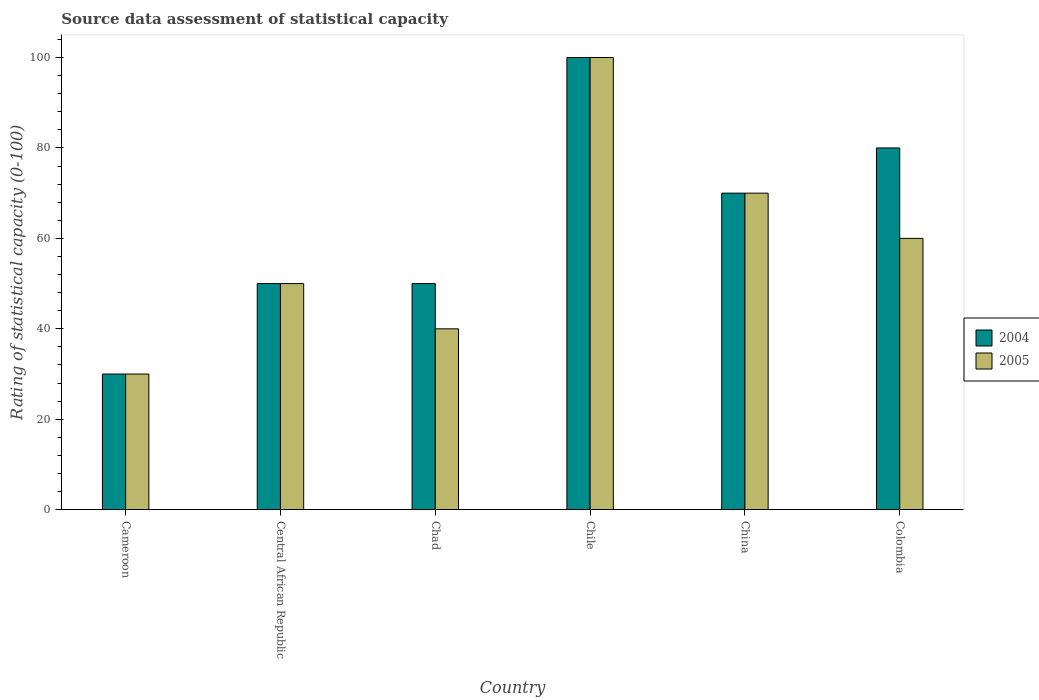How many different coloured bars are there?
Ensure brevity in your answer.  2. How many groups of bars are there?
Offer a very short reply. 6. How many bars are there on the 6th tick from the left?
Offer a very short reply. 2. How many bars are there on the 5th tick from the right?
Give a very brief answer. 2. What is the label of the 5th group of bars from the left?
Ensure brevity in your answer.  China. In which country was the rating of statistical capacity in 2005 minimum?
Make the answer very short. Cameroon. What is the total rating of statistical capacity in 2004 in the graph?
Your answer should be compact. 380. What is the average rating of statistical capacity in 2004 per country?
Your answer should be compact. 63.33. What is the ratio of the rating of statistical capacity in 2004 in Chad to that in China?
Your answer should be very brief. 0.71. Is the difference between the rating of statistical capacity in 2004 in Cameroon and Central African Republic greater than the difference between the rating of statistical capacity in 2005 in Cameroon and Central African Republic?
Your answer should be compact. No. What is the difference between the highest and the lowest rating of statistical capacity in 2005?
Provide a succinct answer. 70. What does the 1st bar from the left in Colombia represents?
Provide a succinct answer. 2004. What does the 2nd bar from the right in Cameroon represents?
Provide a succinct answer. 2004. How many bars are there?
Make the answer very short. 12. Are all the bars in the graph horizontal?
Make the answer very short. No. What is the difference between two consecutive major ticks on the Y-axis?
Provide a short and direct response. 20. Are the values on the major ticks of Y-axis written in scientific E-notation?
Provide a succinct answer. No. Where does the legend appear in the graph?
Your answer should be compact. Center right. What is the title of the graph?
Make the answer very short. Source data assessment of statistical capacity. Does "1988" appear as one of the legend labels in the graph?
Your response must be concise. No. What is the label or title of the X-axis?
Ensure brevity in your answer.  Country. What is the label or title of the Y-axis?
Make the answer very short. Rating of statistical capacity (0-100). What is the Rating of statistical capacity (0-100) in 2005 in Cameroon?
Offer a terse response. 30. What is the Rating of statistical capacity (0-100) of 2004 in China?
Provide a succinct answer. 70. What is the Rating of statistical capacity (0-100) in 2005 in China?
Offer a terse response. 70. What is the Rating of statistical capacity (0-100) in 2004 in Colombia?
Your answer should be very brief. 80. What is the Rating of statistical capacity (0-100) in 2005 in Colombia?
Your answer should be compact. 60. Across all countries, what is the maximum Rating of statistical capacity (0-100) of 2005?
Your answer should be very brief. 100. What is the total Rating of statistical capacity (0-100) in 2004 in the graph?
Your response must be concise. 380. What is the total Rating of statistical capacity (0-100) in 2005 in the graph?
Give a very brief answer. 350. What is the difference between the Rating of statistical capacity (0-100) of 2004 in Cameroon and that in Central African Republic?
Provide a succinct answer. -20. What is the difference between the Rating of statistical capacity (0-100) in 2005 in Cameroon and that in Central African Republic?
Keep it short and to the point. -20. What is the difference between the Rating of statistical capacity (0-100) of 2005 in Cameroon and that in Chad?
Offer a terse response. -10. What is the difference between the Rating of statistical capacity (0-100) of 2004 in Cameroon and that in Chile?
Make the answer very short. -70. What is the difference between the Rating of statistical capacity (0-100) in 2005 in Cameroon and that in Chile?
Offer a very short reply. -70. What is the difference between the Rating of statistical capacity (0-100) in 2004 in Cameroon and that in China?
Your response must be concise. -40. What is the difference between the Rating of statistical capacity (0-100) of 2005 in Cameroon and that in China?
Provide a short and direct response. -40. What is the difference between the Rating of statistical capacity (0-100) in 2004 in Cameroon and that in Colombia?
Your answer should be very brief. -50. What is the difference between the Rating of statistical capacity (0-100) of 2005 in Central African Republic and that in Chad?
Give a very brief answer. 10. What is the difference between the Rating of statistical capacity (0-100) of 2004 in Central African Republic and that in China?
Give a very brief answer. -20. What is the difference between the Rating of statistical capacity (0-100) in 2005 in Central African Republic and that in China?
Offer a very short reply. -20. What is the difference between the Rating of statistical capacity (0-100) of 2004 in Central African Republic and that in Colombia?
Provide a short and direct response. -30. What is the difference between the Rating of statistical capacity (0-100) of 2004 in Chad and that in Chile?
Provide a succinct answer. -50. What is the difference between the Rating of statistical capacity (0-100) in 2005 in Chad and that in Chile?
Your response must be concise. -60. What is the difference between the Rating of statistical capacity (0-100) of 2004 in Chad and that in China?
Ensure brevity in your answer.  -20. What is the difference between the Rating of statistical capacity (0-100) in 2004 in Chad and that in Colombia?
Ensure brevity in your answer.  -30. What is the difference between the Rating of statistical capacity (0-100) in 2005 in Chad and that in Colombia?
Make the answer very short. -20. What is the difference between the Rating of statistical capacity (0-100) of 2005 in Chile and that in China?
Offer a terse response. 30. What is the difference between the Rating of statistical capacity (0-100) in 2004 in Chile and that in Colombia?
Offer a very short reply. 20. What is the difference between the Rating of statistical capacity (0-100) in 2005 in Chile and that in Colombia?
Give a very brief answer. 40. What is the difference between the Rating of statistical capacity (0-100) of 2004 in China and that in Colombia?
Give a very brief answer. -10. What is the difference between the Rating of statistical capacity (0-100) of 2004 in Cameroon and the Rating of statistical capacity (0-100) of 2005 in Central African Republic?
Give a very brief answer. -20. What is the difference between the Rating of statistical capacity (0-100) in 2004 in Cameroon and the Rating of statistical capacity (0-100) in 2005 in Chad?
Give a very brief answer. -10. What is the difference between the Rating of statistical capacity (0-100) of 2004 in Cameroon and the Rating of statistical capacity (0-100) of 2005 in Chile?
Give a very brief answer. -70. What is the difference between the Rating of statistical capacity (0-100) in 2004 in Cameroon and the Rating of statistical capacity (0-100) in 2005 in Colombia?
Give a very brief answer. -30. What is the difference between the Rating of statistical capacity (0-100) of 2004 in Central African Republic and the Rating of statistical capacity (0-100) of 2005 in China?
Your response must be concise. -20. What is the difference between the Rating of statistical capacity (0-100) of 2004 in Chad and the Rating of statistical capacity (0-100) of 2005 in Chile?
Make the answer very short. -50. What is the average Rating of statistical capacity (0-100) in 2004 per country?
Keep it short and to the point. 63.33. What is the average Rating of statistical capacity (0-100) of 2005 per country?
Offer a very short reply. 58.33. What is the difference between the Rating of statistical capacity (0-100) of 2004 and Rating of statistical capacity (0-100) of 2005 in Central African Republic?
Keep it short and to the point. 0. What is the difference between the Rating of statistical capacity (0-100) of 2004 and Rating of statistical capacity (0-100) of 2005 in Chad?
Ensure brevity in your answer.  10. What is the difference between the Rating of statistical capacity (0-100) of 2004 and Rating of statistical capacity (0-100) of 2005 in China?
Your answer should be very brief. 0. What is the ratio of the Rating of statistical capacity (0-100) of 2004 in Cameroon to that in Central African Republic?
Keep it short and to the point. 0.6. What is the ratio of the Rating of statistical capacity (0-100) of 2005 in Cameroon to that in Central African Republic?
Offer a terse response. 0.6. What is the ratio of the Rating of statistical capacity (0-100) in 2004 in Cameroon to that in Chad?
Your answer should be compact. 0.6. What is the ratio of the Rating of statistical capacity (0-100) in 2004 in Cameroon to that in Chile?
Your answer should be very brief. 0.3. What is the ratio of the Rating of statistical capacity (0-100) in 2005 in Cameroon to that in Chile?
Keep it short and to the point. 0.3. What is the ratio of the Rating of statistical capacity (0-100) of 2004 in Cameroon to that in China?
Ensure brevity in your answer.  0.43. What is the ratio of the Rating of statistical capacity (0-100) of 2005 in Cameroon to that in China?
Your response must be concise. 0.43. What is the ratio of the Rating of statistical capacity (0-100) of 2005 in Central African Republic to that in Chad?
Ensure brevity in your answer.  1.25. What is the ratio of the Rating of statistical capacity (0-100) in 2005 in Central African Republic to that in China?
Provide a short and direct response. 0.71. What is the ratio of the Rating of statistical capacity (0-100) of 2005 in Central African Republic to that in Colombia?
Your answer should be very brief. 0.83. What is the ratio of the Rating of statistical capacity (0-100) of 2005 in Chad to that in Chile?
Your answer should be very brief. 0.4. What is the ratio of the Rating of statistical capacity (0-100) of 2005 in Chad to that in China?
Provide a succinct answer. 0.57. What is the ratio of the Rating of statistical capacity (0-100) of 2004 in Chad to that in Colombia?
Offer a terse response. 0.62. What is the ratio of the Rating of statistical capacity (0-100) of 2005 in Chad to that in Colombia?
Keep it short and to the point. 0.67. What is the ratio of the Rating of statistical capacity (0-100) in 2004 in Chile to that in China?
Give a very brief answer. 1.43. What is the ratio of the Rating of statistical capacity (0-100) in 2005 in Chile to that in China?
Provide a short and direct response. 1.43. What is the difference between the highest and the lowest Rating of statistical capacity (0-100) in 2004?
Offer a very short reply. 70. 